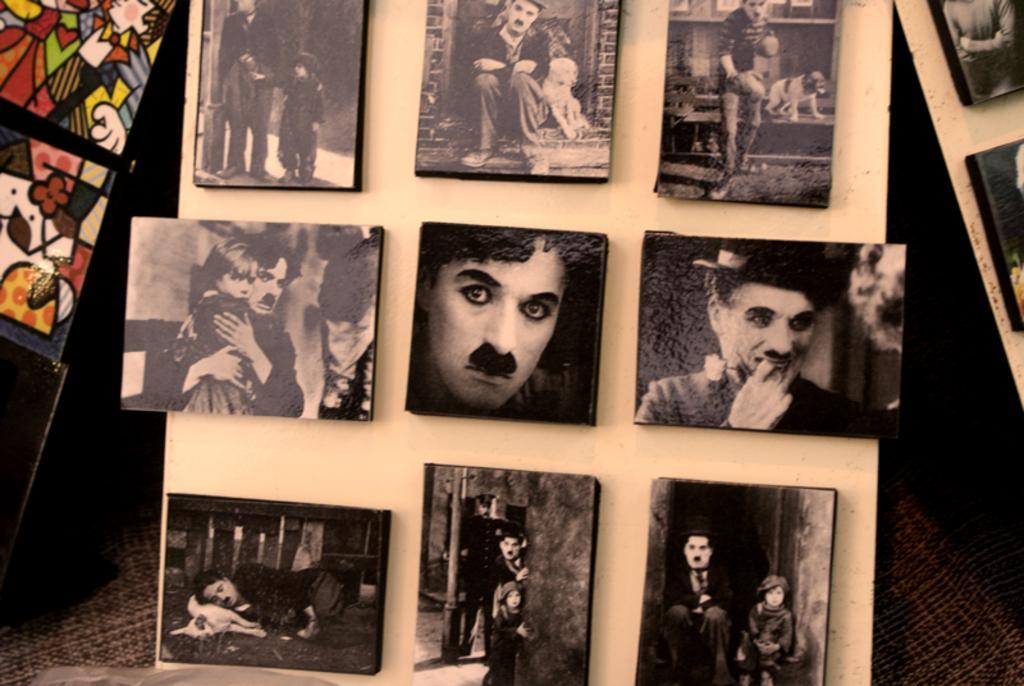Describe this image in one or two sentences. In the middle of the image there is a board with many picture frames on it and there are many pictures of a man in the picture frames. On the left side of the image there is a board with a few paintings on it. On the right side of the image there is a board with two picture frames on it. 